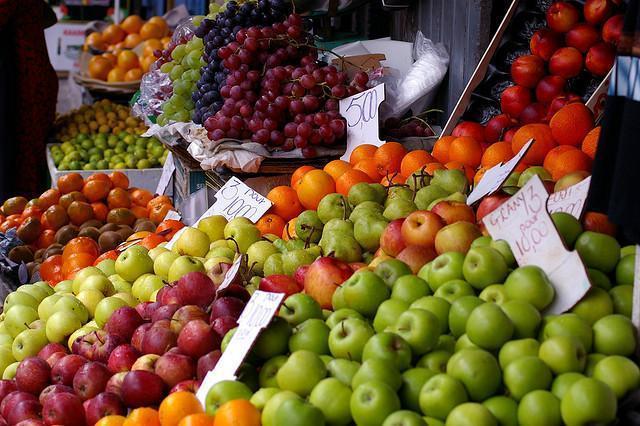How many colors of apples are there?
Give a very brief answer. 3. How many oranges are in the photo?
Give a very brief answer. 3. How many apples can be seen?
Give a very brief answer. 2. How many sheep with horns are on the picture?
Give a very brief answer. 0. 